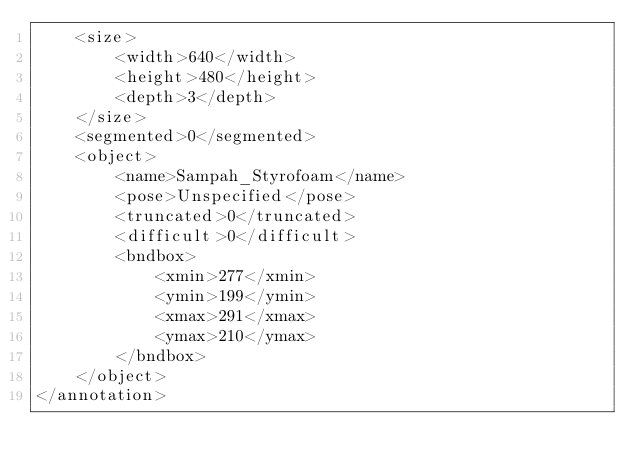<code> <loc_0><loc_0><loc_500><loc_500><_XML_>	<size>
		<width>640</width>
		<height>480</height>
		<depth>3</depth>
	</size>
	<segmented>0</segmented>
	<object>
		<name>Sampah_Styrofoam</name>
		<pose>Unspecified</pose>
		<truncated>0</truncated>
		<difficult>0</difficult>
		<bndbox>
			<xmin>277</xmin>
			<ymin>199</ymin>
			<xmax>291</xmax>
			<ymax>210</ymax>
		</bndbox>
	</object>
</annotation>
</code> 